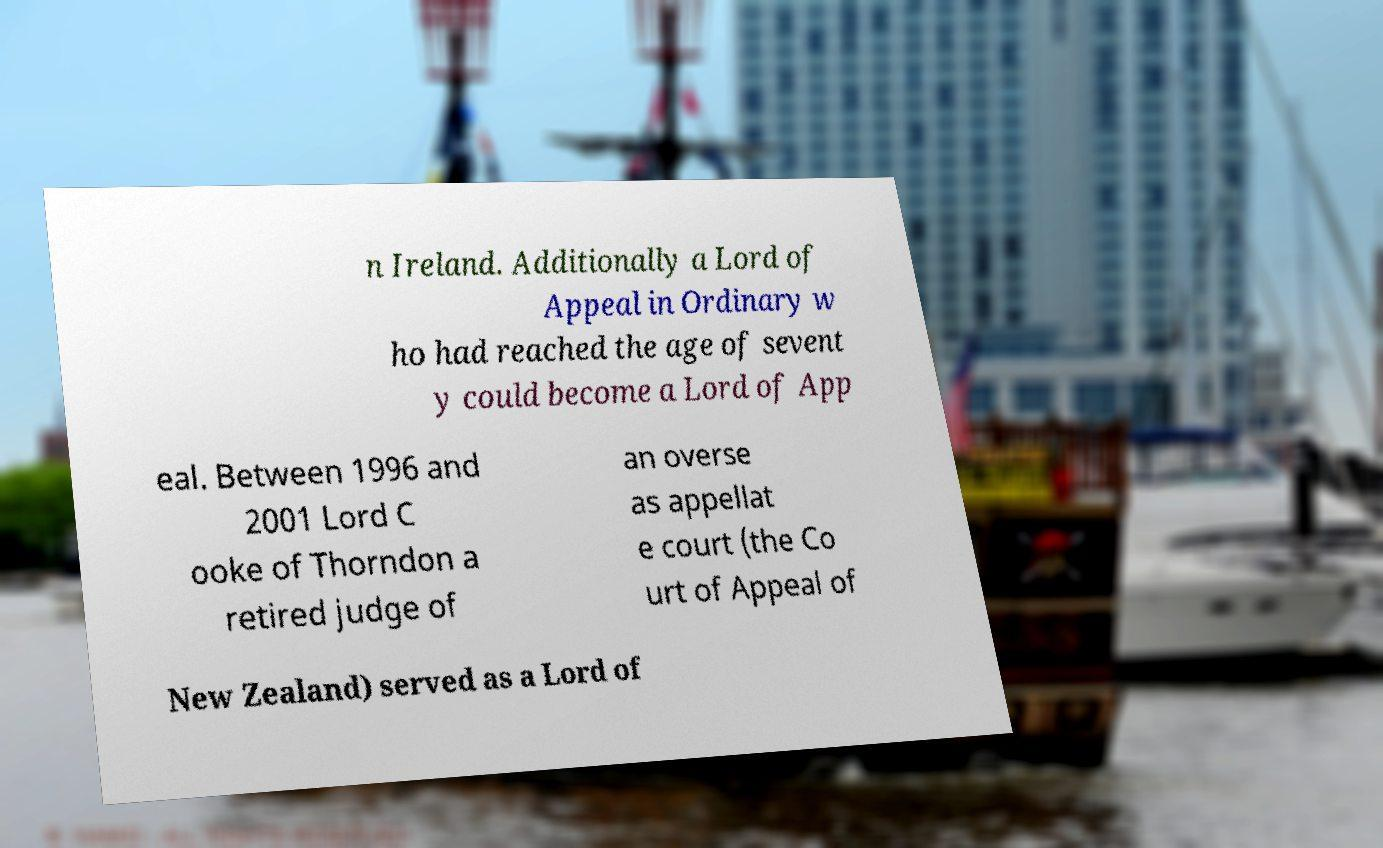I need the written content from this picture converted into text. Can you do that? n Ireland. Additionally a Lord of Appeal in Ordinary w ho had reached the age of sevent y could become a Lord of App eal. Between 1996 and 2001 Lord C ooke of Thorndon a retired judge of an overse as appellat e court (the Co urt of Appeal of New Zealand) served as a Lord of 